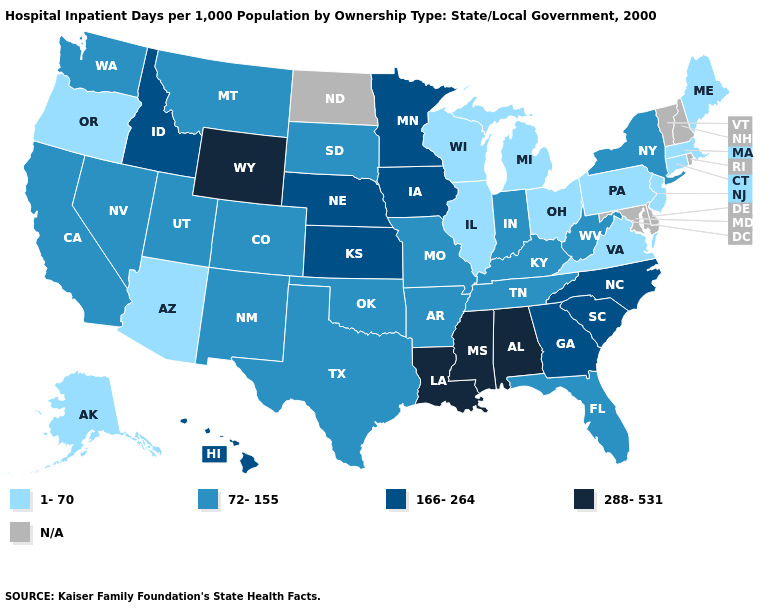What is the lowest value in states that border South Carolina?
Short answer required. 166-264. What is the lowest value in the South?
Short answer required. 1-70. What is the highest value in states that border Oregon?
Keep it brief. 166-264. Which states have the lowest value in the MidWest?
Write a very short answer. Illinois, Michigan, Ohio, Wisconsin. What is the value of California?
Concise answer only. 72-155. Does Idaho have the highest value in the USA?
Be succinct. No. Name the states that have a value in the range N/A?
Keep it brief. Delaware, Maryland, New Hampshire, North Dakota, Rhode Island, Vermont. Does Ohio have the highest value in the USA?
Short answer required. No. Name the states that have a value in the range 288-531?
Concise answer only. Alabama, Louisiana, Mississippi, Wyoming. What is the lowest value in the West?
Keep it brief. 1-70. Does Minnesota have the highest value in the USA?
Short answer required. No. Among the states that border Arkansas , does Mississippi have the lowest value?
Short answer required. No. Among the states that border New Mexico , does Oklahoma have the lowest value?
Short answer required. No. 